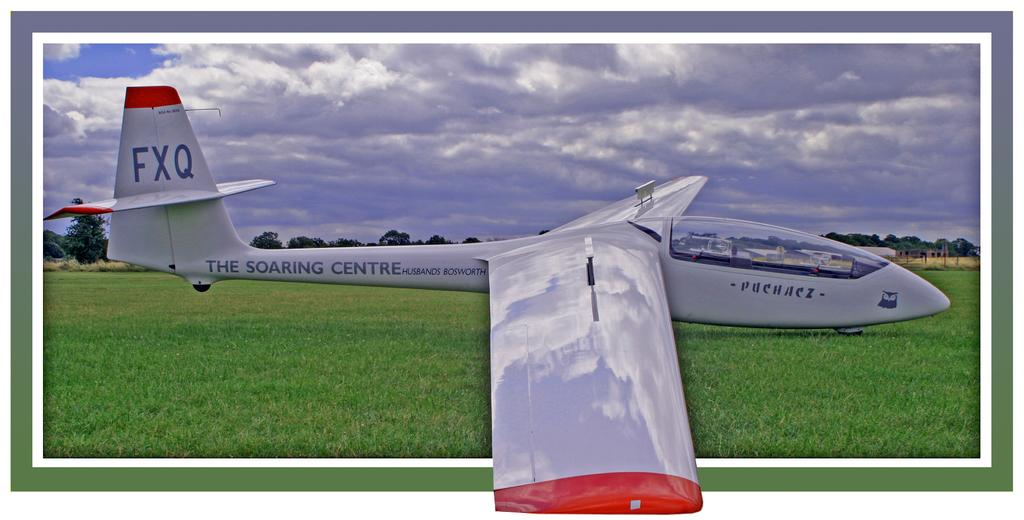Provide a one-sentence caption for the provided image. the soaring centre plane appears to be strangely shaped. 